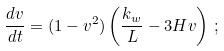<formula> <loc_0><loc_0><loc_500><loc_500>\frac { d v } { d t } = ( 1 - v ^ { 2 } ) \left ( \frac { k _ { w } } { L } - 3 H v \right ) \, ;</formula> 